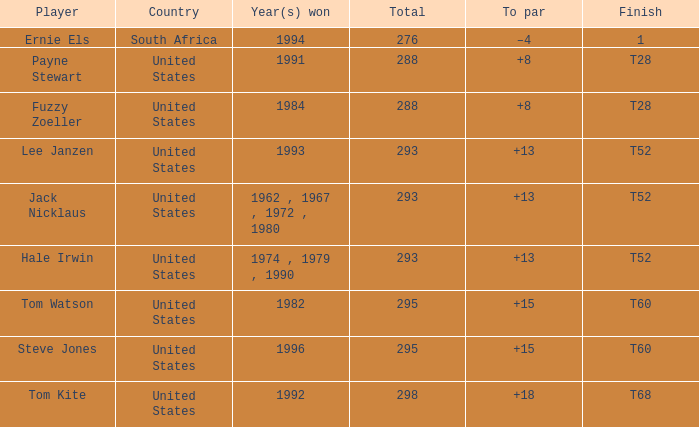Who is the player from the United States with a total less than 293 and won in 1984? Fuzzy Zoeller. 